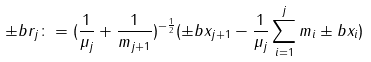<formula> <loc_0><loc_0><loc_500><loc_500>\pm b { r } _ { j } \colon = ( \frac { 1 } { \mu _ { j } } + \frac { 1 } { m _ { j + 1 } } ) ^ { - \frac { 1 } { 2 } } ( \pm b { x } _ { j + 1 } - \frac { 1 } { \mu _ { j } } \sum ^ { j } _ { i = 1 } m _ { i } \pm b { x } _ { i } )</formula> 